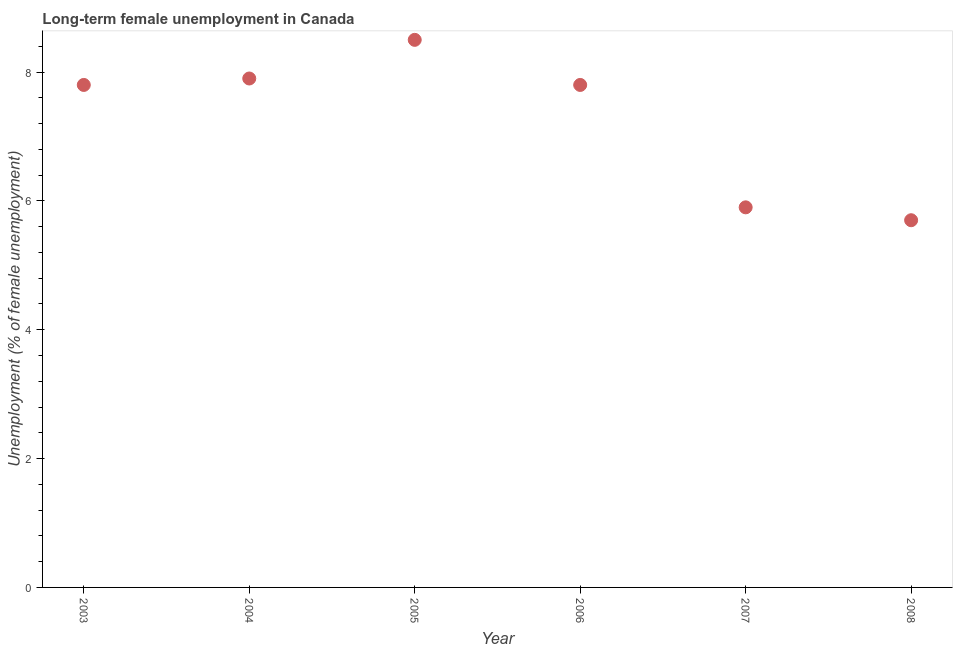What is the long-term female unemployment in 2007?
Your answer should be compact. 5.9. Across all years, what is the minimum long-term female unemployment?
Keep it short and to the point. 5.7. What is the sum of the long-term female unemployment?
Offer a terse response. 43.6. What is the difference between the long-term female unemployment in 2007 and 2008?
Offer a very short reply. 0.2. What is the average long-term female unemployment per year?
Provide a short and direct response. 7.27. What is the median long-term female unemployment?
Ensure brevity in your answer.  7.8. In how many years, is the long-term female unemployment greater than 7.2 %?
Your response must be concise. 4. What is the ratio of the long-term female unemployment in 2005 to that in 2006?
Offer a very short reply. 1.09. Is the long-term female unemployment in 2004 less than that in 2007?
Your answer should be compact. No. What is the difference between the highest and the second highest long-term female unemployment?
Give a very brief answer. 0.6. Is the sum of the long-term female unemployment in 2007 and 2008 greater than the maximum long-term female unemployment across all years?
Your answer should be very brief. Yes. What is the difference between the highest and the lowest long-term female unemployment?
Offer a terse response. 2.8. In how many years, is the long-term female unemployment greater than the average long-term female unemployment taken over all years?
Your answer should be compact. 4. How many dotlines are there?
Offer a terse response. 1. How many years are there in the graph?
Offer a terse response. 6. What is the difference between two consecutive major ticks on the Y-axis?
Ensure brevity in your answer.  2. Does the graph contain any zero values?
Offer a terse response. No. Does the graph contain grids?
Give a very brief answer. No. What is the title of the graph?
Make the answer very short. Long-term female unemployment in Canada. What is the label or title of the Y-axis?
Provide a short and direct response. Unemployment (% of female unemployment). What is the Unemployment (% of female unemployment) in 2003?
Give a very brief answer. 7.8. What is the Unemployment (% of female unemployment) in 2004?
Keep it short and to the point. 7.9. What is the Unemployment (% of female unemployment) in 2005?
Your response must be concise. 8.5. What is the Unemployment (% of female unemployment) in 2006?
Your answer should be very brief. 7.8. What is the Unemployment (% of female unemployment) in 2007?
Keep it short and to the point. 5.9. What is the Unemployment (% of female unemployment) in 2008?
Provide a succinct answer. 5.7. What is the difference between the Unemployment (% of female unemployment) in 2003 and 2004?
Offer a terse response. -0.1. What is the difference between the Unemployment (% of female unemployment) in 2003 and 2005?
Your answer should be very brief. -0.7. What is the difference between the Unemployment (% of female unemployment) in 2003 and 2006?
Give a very brief answer. 0. What is the difference between the Unemployment (% of female unemployment) in 2003 and 2007?
Your answer should be very brief. 1.9. What is the difference between the Unemployment (% of female unemployment) in 2004 and 2007?
Ensure brevity in your answer.  2. What is the difference between the Unemployment (% of female unemployment) in 2005 and 2006?
Your answer should be compact. 0.7. What is the difference between the Unemployment (% of female unemployment) in 2005 and 2008?
Give a very brief answer. 2.8. What is the difference between the Unemployment (% of female unemployment) in 2006 and 2007?
Provide a short and direct response. 1.9. What is the ratio of the Unemployment (% of female unemployment) in 2003 to that in 2004?
Make the answer very short. 0.99. What is the ratio of the Unemployment (% of female unemployment) in 2003 to that in 2005?
Give a very brief answer. 0.92. What is the ratio of the Unemployment (% of female unemployment) in 2003 to that in 2006?
Provide a succinct answer. 1. What is the ratio of the Unemployment (% of female unemployment) in 2003 to that in 2007?
Ensure brevity in your answer.  1.32. What is the ratio of the Unemployment (% of female unemployment) in 2003 to that in 2008?
Your answer should be compact. 1.37. What is the ratio of the Unemployment (% of female unemployment) in 2004 to that in 2005?
Ensure brevity in your answer.  0.93. What is the ratio of the Unemployment (% of female unemployment) in 2004 to that in 2006?
Offer a terse response. 1.01. What is the ratio of the Unemployment (% of female unemployment) in 2004 to that in 2007?
Make the answer very short. 1.34. What is the ratio of the Unemployment (% of female unemployment) in 2004 to that in 2008?
Your answer should be very brief. 1.39. What is the ratio of the Unemployment (% of female unemployment) in 2005 to that in 2006?
Your response must be concise. 1.09. What is the ratio of the Unemployment (% of female unemployment) in 2005 to that in 2007?
Your answer should be very brief. 1.44. What is the ratio of the Unemployment (% of female unemployment) in 2005 to that in 2008?
Ensure brevity in your answer.  1.49. What is the ratio of the Unemployment (% of female unemployment) in 2006 to that in 2007?
Keep it short and to the point. 1.32. What is the ratio of the Unemployment (% of female unemployment) in 2006 to that in 2008?
Your answer should be compact. 1.37. What is the ratio of the Unemployment (% of female unemployment) in 2007 to that in 2008?
Your response must be concise. 1.03. 